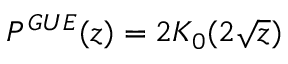<formula> <loc_0><loc_0><loc_500><loc_500>P ^ { G U E } ( z ) = 2 K _ { 0 } ( 2 \sqrt { z } )</formula> 